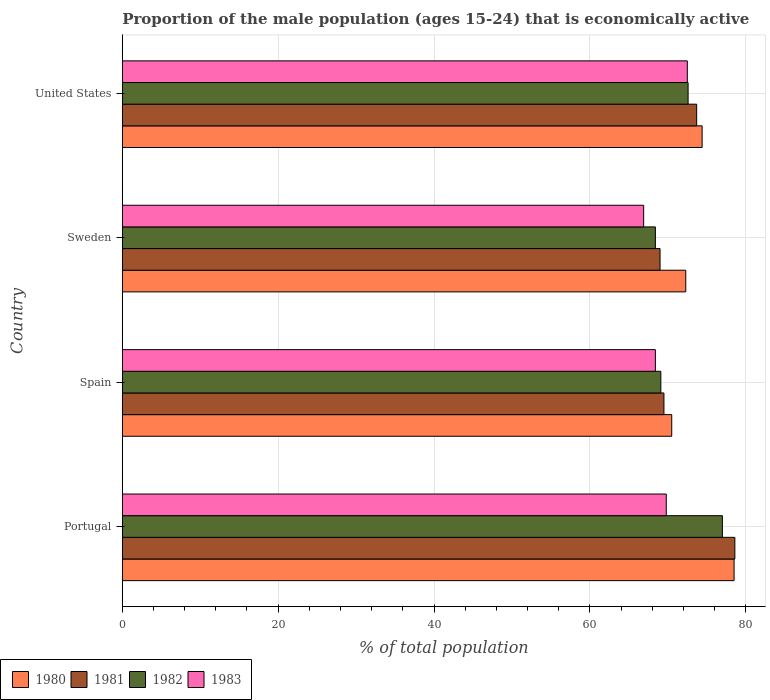How many different coloured bars are there?
Give a very brief answer. 4. How many groups of bars are there?
Make the answer very short. 4. Are the number of bars per tick equal to the number of legend labels?
Offer a terse response. Yes. Are the number of bars on each tick of the Y-axis equal?
Your answer should be compact. Yes. How many bars are there on the 3rd tick from the top?
Provide a short and direct response. 4. In how many cases, is the number of bars for a given country not equal to the number of legend labels?
Provide a short and direct response. 0. What is the proportion of the male population that is economically active in 1982 in Portugal?
Provide a succinct answer. 77. Across all countries, what is the maximum proportion of the male population that is economically active in 1983?
Give a very brief answer. 72.5. Across all countries, what is the minimum proportion of the male population that is economically active in 1981?
Provide a succinct answer. 69. What is the total proportion of the male population that is economically active in 1980 in the graph?
Offer a very short reply. 295.7. What is the difference between the proportion of the male population that is economically active in 1980 in United States and the proportion of the male population that is economically active in 1981 in Portugal?
Keep it short and to the point. -4.2. What is the average proportion of the male population that is economically active in 1980 per country?
Your answer should be compact. 73.93. What is the difference between the proportion of the male population that is economically active in 1981 and proportion of the male population that is economically active in 1982 in United States?
Your answer should be compact. 1.1. In how many countries, is the proportion of the male population that is economically active in 1981 greater than 64 %?
Your response must be concise. 4. What is the ratio of the proportion of the male population that is economically active in 1980 in Sweden to that in United States?
Provide a succinct answer. 0.97. What is the difference between the highest and the second highest proportion of the male population that is economically active in 1982?
Your answer should be compact. 4.4. What is the difference between the highest and the lowest proportion of the male population that is economically active in 1983?
Offer a very short reply. 5.6. Is it the case that in every country, the sum of the proportion of the male population that is economically active in 1981 and proportion of the male population that is economically active in 1982 is greater than the sum of proportion of the male population that is economically active in 1980 and proportion of the male population that is economically active in 1983?
Provide a succinct answer. No. What does the 2nd bar from the top in Spain represents?
Your answer should be compact. 1982. Is it the case that in every country, the sum of the proportion of the male population that is economically active in 1981 and proportion of the male population that is economically active in 1980 is greater than the proportion of the male population that is economically active in 1982?
Offer a terse response. Yes. How many bars are there?
Keep it short and to the point. 16. How many countries are there in the graph?
Give a very brief answer. 4. Does the graph contain any zero values?
Offer a very short reply. No. Does the graph contain grids?
Your response must be concise. Yes. What is the title of the graph?
Your answer should be very brief. Proportion of the male population (ages 15-24) that is economically active. Does "2013" appear as one of the legend labels in the graph?
Offer a very short reply. No. What is the label or title of the X-axis?
Offer a terse response. % of total population. What is the label or title of the Y-axis?
Keep it short and to the point. Country. What is the % of total population in 1980 in Portugal?
Your answer should be very brief. 78.5. What is the % of total population in 1981 in Portugal?
Make the answer very short. 78.6. What is the % of total population in 1982 in Portugal?
Your response must be concise. 77. What is the % of total population in 1983 in Portugal?
Make the answer very short. 69.8. What is the % of total population of 1980 in Spain?
Provide a short and direct response. 70.5. What is the % of total population of 1981 in Spain?
Give a very brief answer. 69.5. What is the % of total population of 1982 in Spain?
Keep it short and to the point. 69.1. What is the % of total population in 1983 in Spain?
Ensure brevity in your answer.  68.4. What is the % of total population of 1980 in Sweden?
Ensure brevity in your answer.  72.3. What is the % of total population in 1982 in Sweden?
Offer a very short reply. 68.4. What is the % of total population of 1983 in Sweden?
Offer a very short reply. 66.9. What is the % of total population of 1980 in United States?
Your answer should be very brief. 74.4. What is the % of total population of 1981 in United States?
Your answer should be compact. 73.7. What is the % of total population in 1982 in United States?
Your answer should be compact. 72.6. What is the % of total population in 1983 in United States?
Ensure brevity in your answer.  72.5. Across all countries, what is the maximum % of total population of 1980?
Keep it short and to the point. 78.5. Across all countries, what is the maximum % of total population of 1981?
Ensure brevity in your answer.  78.6. Across all countries, what is the maximum % of total population of 1982?
Keep it short and to the point. 77. Across all countries, what is the maximum % of total population in 1983?
Provide a short and direct response. 72.5. Across all countries, what is the minimum % of total population of 1980?
Give a very brief answer. 70.5. Across all countries, what is the minimum % of total population in 1982?
Provide a short and direct response. 68.4. Across all countries, what is the minimum % of total population of 1983?
Make the answer very short. 66.9. What is the total % of total population of 1980 in the graph?
Provide a short and direct response. 295.7. What is the total % of total population in 1981 in the graph?
Ensure brevity in your answer.  290.8. What is the total % of total population in 1982 in the graph?
Offer a terse response. 287.1. What is the total % of total population in 1983 in the graph?
Provide a short and direct response. 277.6. What is the difference between the % of total population in 1980 in Portugal and that in Spain?
Your answer should be compact. 8. What is the difference between the % of total population of 1982 in Portugal and that in Spain?
Your response must be concise. 7.9. What is the difference between the % of total population in 1983 in Portugal and that in Spain?
Your response must be concise. 1.4. What is the difference between the % of total population in 1983 in Portugal and that in Sweden?
Provide a short and direct response. 2.9. What is the difference between the % of total population in 1981 in Portugal and that in United States?
Make the answer very short. 4.9. What is the difference between the % of total population of 1982 in Portugal and that in United States?
Provide a short and direct response. 4.4. What is the difference between the % of total population of 1980 in Spain and that in Sweden?
Give a very brief answer. -1.8. What is the difference between the % of total population in 1983 in Spain and that in Sweden?
Ensure brevity in your answer.  1.5. What is the difference between the % of total population in 1980 in Spain and that in United States?
Provide a short and direct response. -3.9. What is the difference between the % of total population of 1982 in Sweden and that in United States?
Provide a succinct answer. -4.2. What is the difference between the % of total population of 1980 in Portugal and the % of total population of 1981 in Spain?
Offer a terse response. 9. What is the difference between the % of total population of 1980 in Portugal and the % of total population of 1983 in Spain?
Your answer should be very brief. 10.1. What is the difference between the % of total population in 1980 in Portugal and the % of total population in 1983 in Sweden?
Keep it short and to the point. 11.6. What is the difference between the % of total population of 1981 in Portugal and the % of total population of 1982 in United States?
Your answer should be very brief. 6. What is the difference between the % of total population of 1981 in Portugal and the % of total population of 1983 in United States?
Provide a succinct answer. 6.1. What is the difference between the % of total population of 1980 in Spain and the % of total population of 1981 in Sweden?
Your response must be concise. 1.5. What is the difference between the % of total population in 1981 in Spain and the % of total population in 1983 in Sweden?
Your answer should be compact. 2.6. What is the difference between the % of total population in 1980 in Spain and the % of total population in 1981 in United States?
Provide a succinct answer. -3.2. What is the difference between the % of total population of 1980 in Spain and the % of total population of 1982 in United States?
Give a very brief answer. -2.1. What is the difference between the % of total population in 1981 in Spain and the % of total population in 1983 in United States?
Your answer should be very brief. -3. What is the difference between the % of total population in 1982 in Spain and the % of total population in 1983 in United States?
Offer a very short reply. -3.4. What is the difference between the % of total population of 1980 in Sweden and the % of total population of 1983 in United States?
Keep it short and to the point. -0.2. What is the average % of total population in 1980 per country?
Provide a short and direct response. 73.92. What is the average % of total population of 1981 per country?
Ensure brevity in your answer.  72.7. What is the average % of total population in 1982 per country?
Offer a very short reply. 71.78. What is the average % of total population in 1983 per country?
Give a very brief answer. 69.4. What is the difference between the % of total population in 1980 and % of total population in 1981 in Portugal?
Your response must be concise. -0.1. What is the difference between the % of total population of 1981 and % of total population of 1982 in Portugal?
Give a very brief answer. 1.6. What is the difference between the % of total population of 1981 and % of total population of 1983 in Portugal?
Your response must be concise. 8.8. What is the difference between the % of total population of 1980 and % of total population of 1981 in Spain?
Your response must be concise. 1. What is the difference between the % of total population in 1981 and % of total population in 1982 in Spain?
Keep it short and to the point. 0.4. What is the difference between the % of total population of 1982 and % of total population of 1983 in Spain?
Keep it short and to the point. 0.7. What is the difference between the % of total population of 1980 and % of total population of 1982 in Sweden?
Make the answer very short. 3.9. What is the difference between the % of total population of 1980 and % of total population of 1983 in Sweden?
Your answer should be compact. 5.4. What is the difference between the % of total population in 1981 and % of total population in 1982 in Sweden?
Keep it short and to the point. 0.6. What is the difference between the % of total population in 1981 and % of total population in 1983 in Sweden?
Your response must be concise. 2.1. What is the difference between the % of total population of 1982 and % of total population of 1983 in Sweden?
Give a very brief answer. 1.5. What is the difference between the % of total population of 1980 and % of total population of 1982 in United States?
Make the answer very short. 1.8. What is the difference between the % of total population in 1981 and % of total population in 1982 in United States?
Your answer should be very brief. 1.1. What is the ratio of the % of total population in 1980 in Portugal to that in Spain?
Ensure brevity in your answer.  1.11. What is the ratio of the % of total population in 1981 in Portugal to that in Spain?
Provide a succinct answer. 1.13. What is the ratio of the % of total population in 1982 in Portugal to that in Spain?
Make the answer very short. 1.11. What is the ratio of the % of total population of 1983 in Portugal to that in Spain?
Your answer should be very brief. 1.02. What is the ratio of the % of total population of 1980 in Portugal to that in Sweden?
Offer a terse response. 1.09. What is the ratio of the % of total population in 1981 in Portugal to that in Sweden?
Keep it short and to the point. 1.14. What is the ratio of the % of total population in 1982 in Portugal to that in Sweden?
Offer a very short reply. 1.13. What is the ratio of the % of total population of 1983 in Portugal to that in Sweden?
Make the answer very short. 1.04. What is the ratio of the % of total population of 1980 in Portugal to that in United States?
Provide a short and direct response. 1.06. What is the ratio of the % of total population of 1981 in Portugal to that in United States?
Offer a very short reply. 1.07. What is the ratio of the % of total population in 1982 in Portugal to that in United States?
Offer a terse response. 1.06. What is the ratio of the % of total population of 1983 in Portugal to that in United States?
Keep it short and to the point. 0.96. What is the ratio of the % of total population of 1980 in Spain to that in Sweden?
Keep it short and to the point. 0.98. What is the ratio of the % of total population of 1982 in Spain to that in Sweden?
Your response must be concise. 1.01. What is the ratio of the % of total population in 1983 in Spain to that in Sweden?
Your response must be concise. 1.02. What is the ratio of the % of total population of 1980 in Spain to that in United States?
Your answer should be very brief. 0.95. What is the ratio of the % of total population in 1981 in Spain to that in United States?
Make the answer very short. 0.94. What is the ratio of the % of total population of 1982 in Spain to that in United States?
Keep it short and to the point. 0.95. What is the ratio of the % of total population of 1983 in Spain to that in United States?
Your response must be concise. 0.94. What is the ratio of the % of total population of 1980 in Sweden to that in United States?
Ensure brevity in your answer.  0.97. What is the ratio of the % of total population of 1981 in Sweden to that in United States?
Make the answer very short. 0.94. What is the ratio of the % of total population in 1982 in Sweden to that in United States?
Keep it short and to the point. 0.94. What is the ratio of the % of total population in 1983 in Sweden to that in United States?
Offer a terse response. 0.92. What is the difference between the highest and the second highest % of total population in 1980?
Make the answer very short. 4.1. What is the difference between the highest and the second highest % of total population in 1981?
Provide a succinct answer. 4.9. What is the difference between the highest and the second highest % of total population in 1983?
Keep it short and to the point. 2.7. What is the difference between the highest and the lowest % of total population of 1981?
Provide a short and direct response. 9.6. What is the difference between the highest and the lowest % of total population in 1982?
Give a very brief answer. 8.6. 